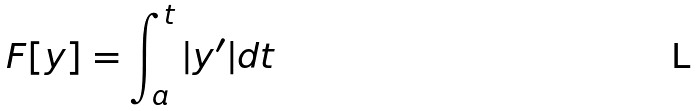Convert formula to latex. <formula><loc_0><loc_0><loc_500><loc_500>F [ y ] = \int _ { a } ^ { t } | y ^ { \prime } | d t</formula> 